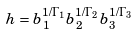Convert formula to latex. <formula><loc_0><loc_0><loc_500><loc_500>h = b _ { 1 } ^ { 1 / \Gamma _ { 1 } } b _ { 2 } ^ { 1 / \Gamma _ { 2 } } b _ { 3 } ^ { 1 / \Gamma _ { 3 } }</formula> 